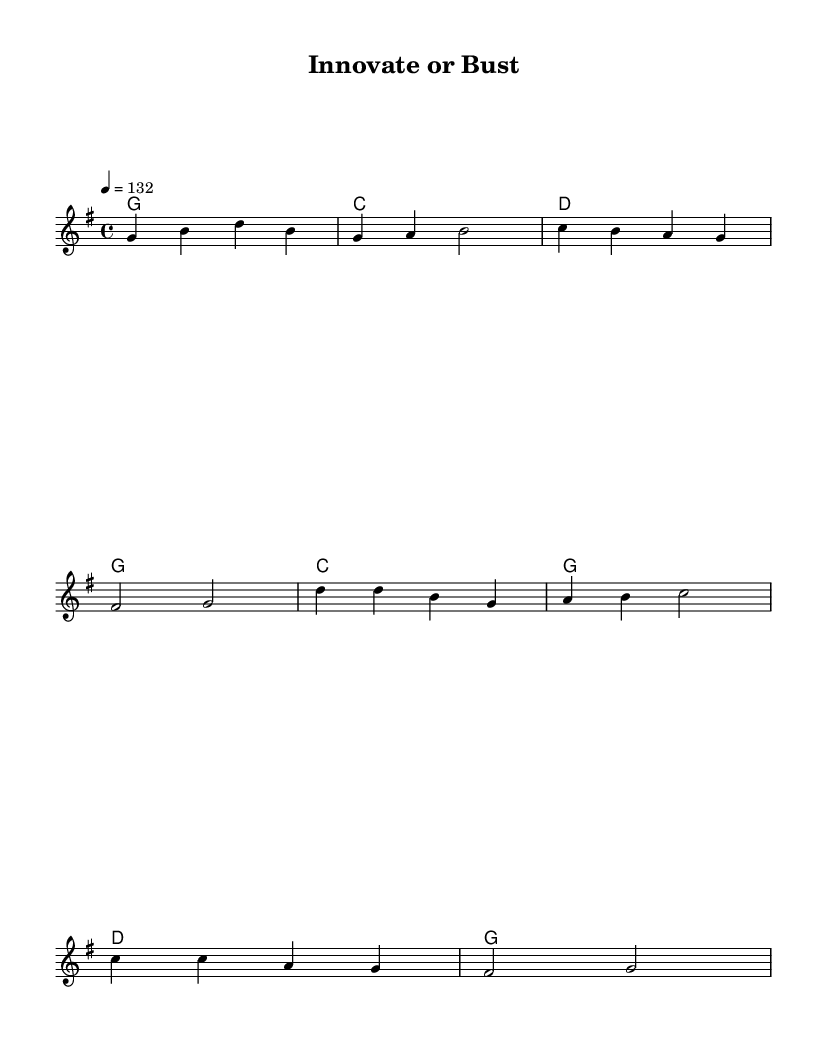What is the key signature of this music? The key signature is G major, which has one sharp note (F#). This is determined from the global music settings specified at the beginning of the code.
Answer: G major What is the time signature of this piece? The time signature is 4/4, indicating four beats per measure. This is also found in the global music settings.
Answer: 4/4 What is the tempo marking for this piece? The tempo is marked at 132 beats per minute, as indicated in the global settings. This suggests a fast and lively pace suitable for country rock.
Answer: 132 How many verses are there in this song? The song has one verse before the chorus is repeated. This can be inferred from the structure laid out in the sheet music where the verse is clearly defined before transitioning to the chorus.
Answer: One What is the lyrical theme of the chorus? The theme is about innovation and overcoming barriers in the face of challenges, which is a central message in the lyrics provided for the chorus.
Answer: Innovation What is the last chord in the song? The last chord in the score is G major, as indicated in the chord progression toward the end of the piece. This can be found under the harmonies section corresponding to the chorus.
Answer: G What kind of challenges does the song address? The song addresses challenges related to finding solutions in business through innovation and creativity. This theme is reflected in both the verse and chorus lyrics.
Answer: Problem-solving 